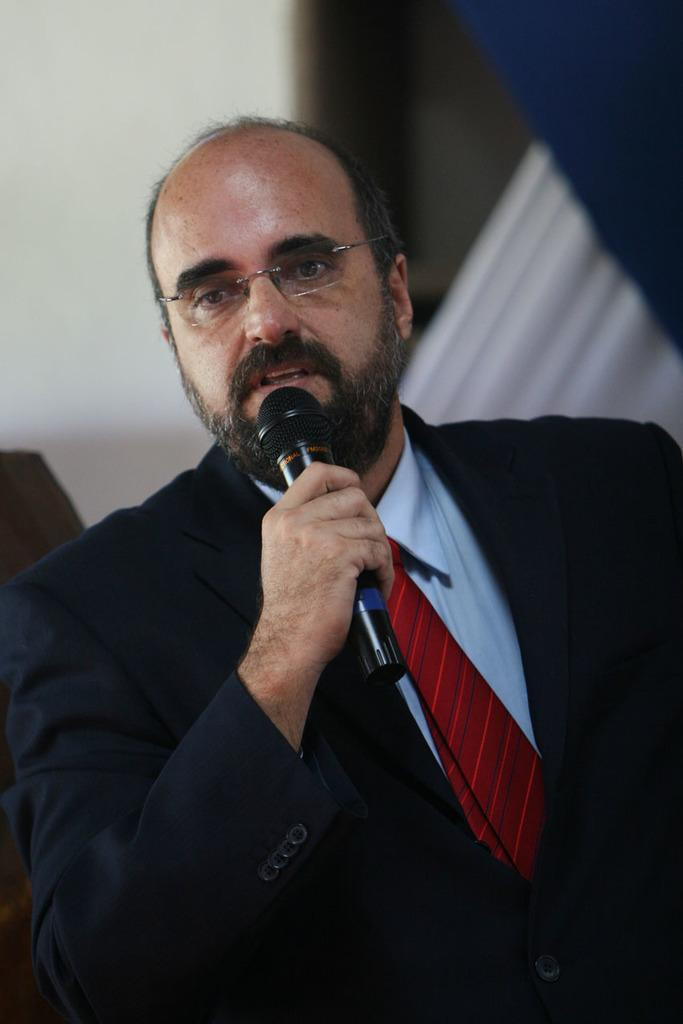Who is the person in the image? There is a man in the image. What is the man wearing? The man is wearing spectacles. What is the man holding in his hand? The man is holding a microphone in his hand. What is the man doing in the image? The man is talking. What can be seen above the man in the image? There is a ceiling visible in the image. What can be seen to the side of the man in the image? There is a wall visible in the image. How many apples are on the giraffe's head in the image? There is no giraffe or apples present in the image. 